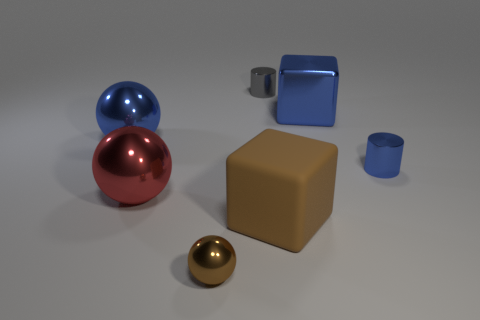How is the lighting affecting the appearance of the objects? The lighting creates a soft glow on the surfaces of the objects with gentle shadows behind them. It highlights the shiny texture of the spheres and gives a smooth appearance to the cube and cup. 